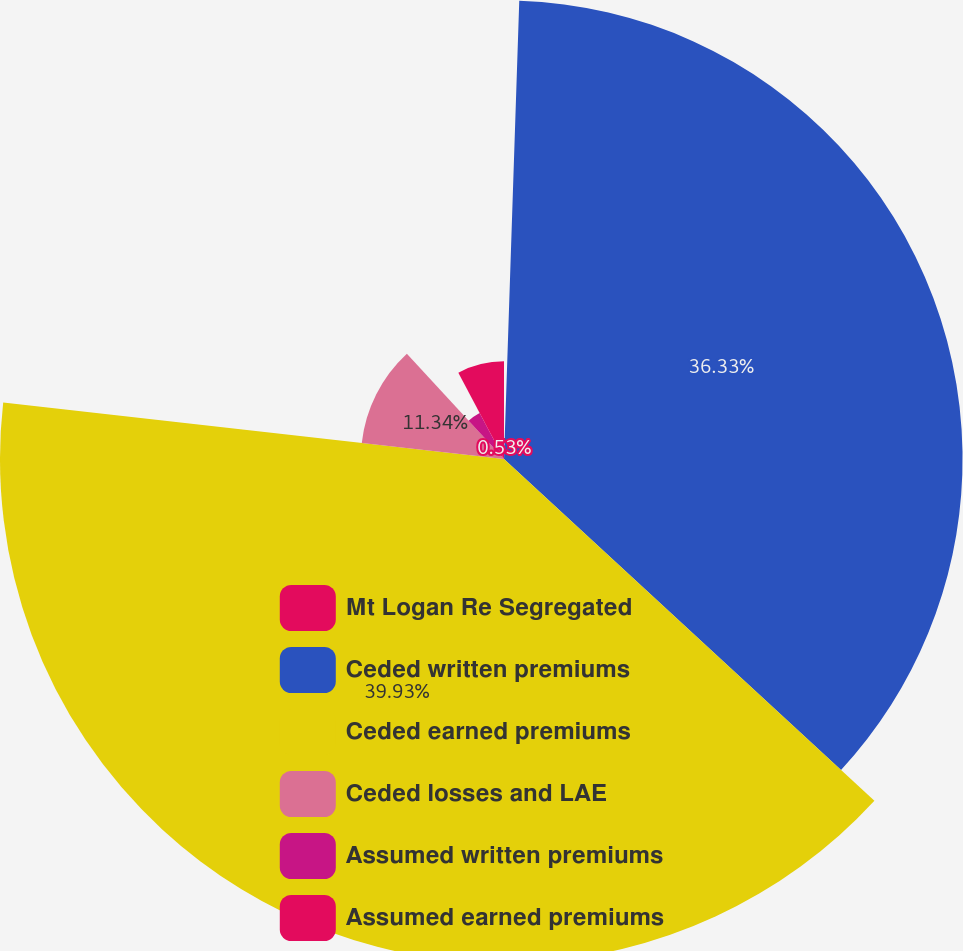<chart> <loc_0><loc_0><loc_500><loc_500><pie_chart><fcel>Mt Logan Re Segregated<fcel>Ceded written premiums<fcel>Ceded earned premiums<fcel>Ceded losses and LAE<fcel>Assumed written premiums<fcel>Assumed earned premiums<nl><fcel>0.53%<fcel>36.33%<fcel>39.93%<fcel>11.34%<fcel>4.13%<fcel>7.74%<nl></chart> 